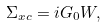<formula> <loc_0><loc_0><loc_500><loc_500>\Sigma _ { x c } = i G _ { 0 } W ,</formula> 